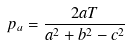<formula> <loc_0><loc_0><loc_500><loc_500>p _ { a } = \frac { 2 a T } { a ^ { 2 } + b ^ { 2 } - c ^ { 2 } }</formula> 